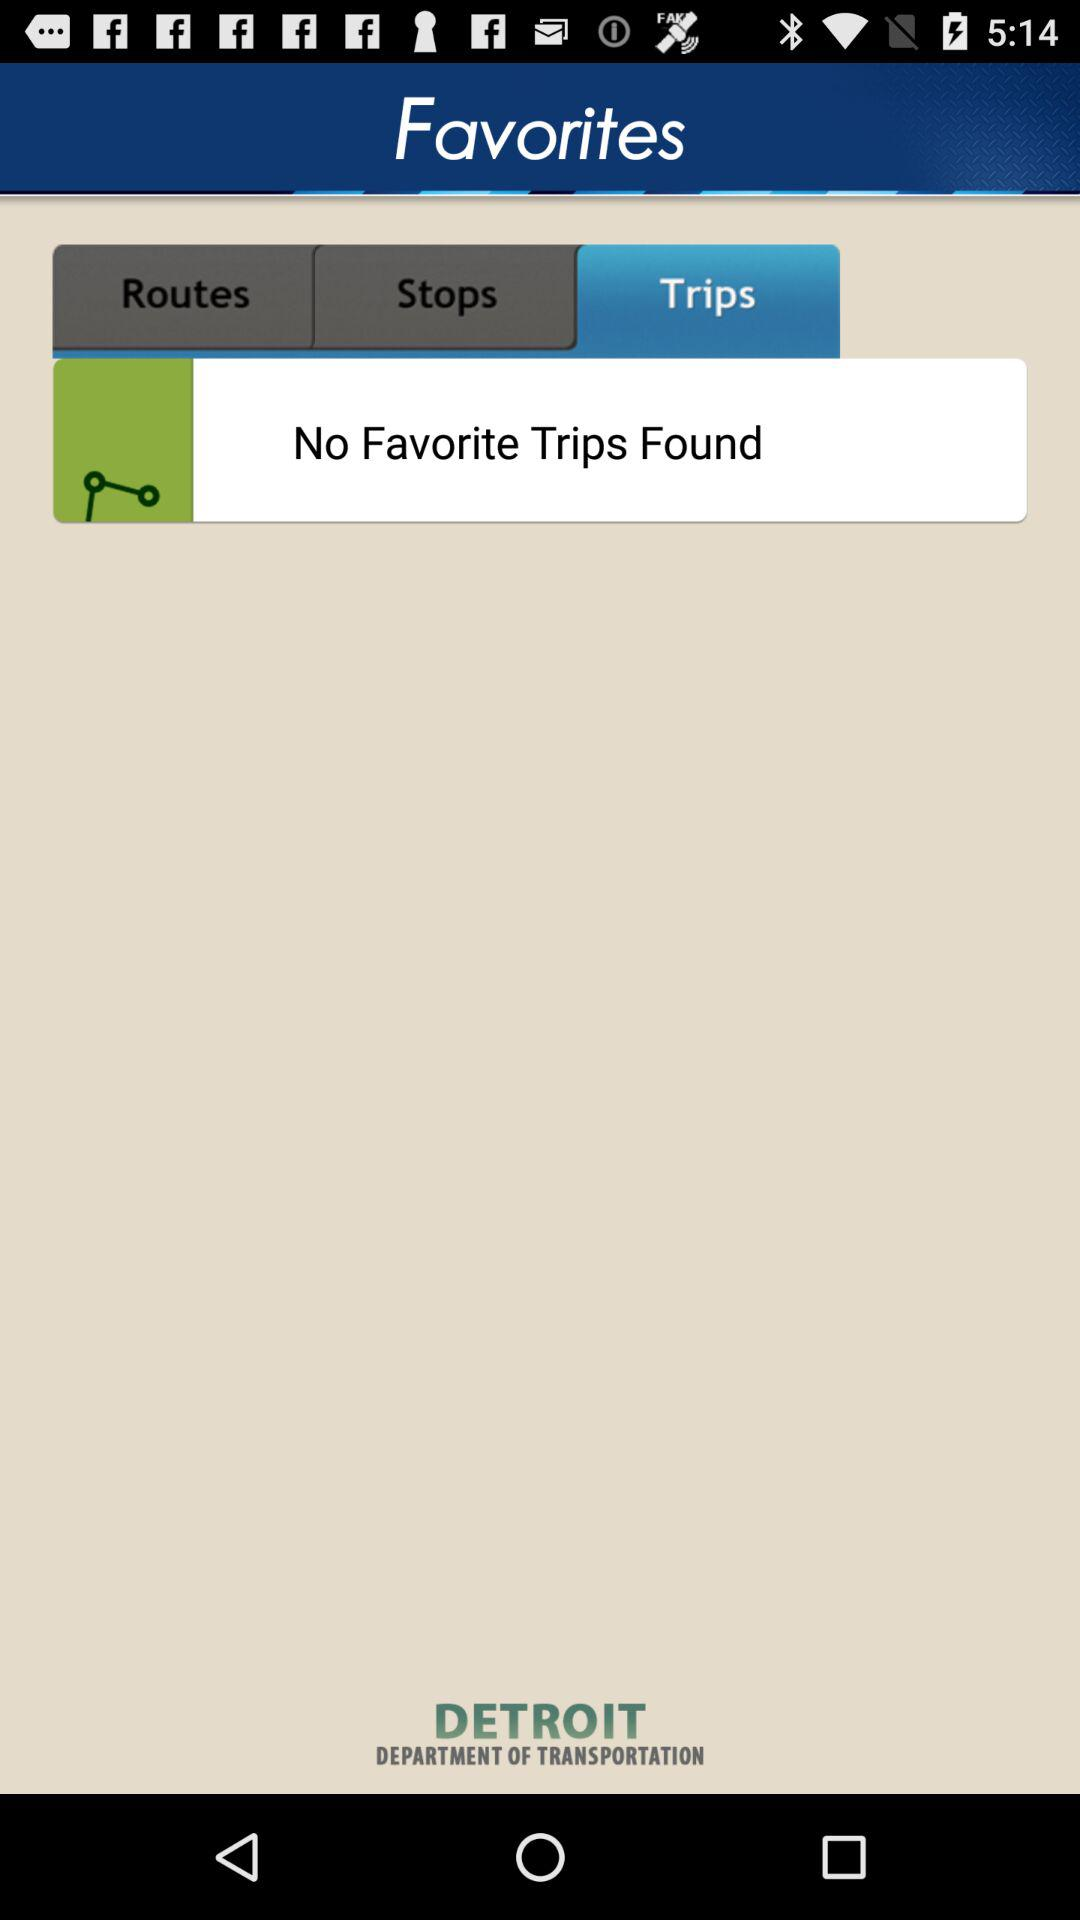Which tab am I on? You are on the "Trips" tab. 